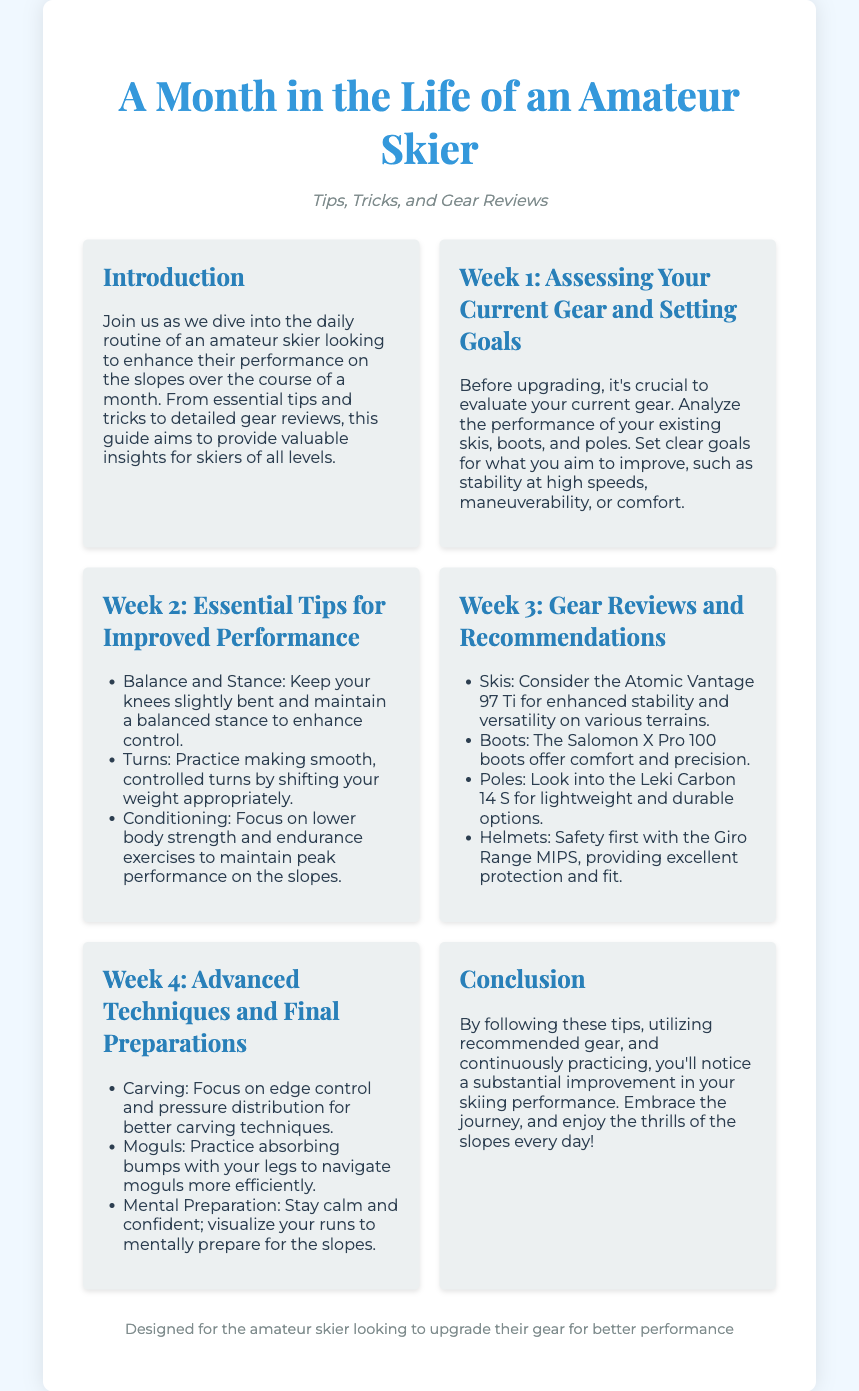What is the title of the document? The title is clearly stated at the top of the Playbill as the main heading.
Answer: A Month in the Life of an Amateur Skier What is the subtitle? The subtitle follows the title and indicates the focus of the content.
Answer: Tips, Tricks, and Gear Reviews What gear is recommended for improved stability? The document includes specific recommendations for gear in Week 3 under gear reviews.
Answer: Atomic Vantage 97 Ti What is one essential tip for improved performance? Essential tips for performance are listed in Week 2 of the document.
Answer: Balance and Stance Which week focuses on advanced techniques? Each week is dedicated to specific themes, and this week is explicitly mentioned.
Answer: Week 4 What is the main focus in Week 1? Week 1's focus is about evaluating existing equipment and setting goals.
Answer: Assessing Your Current Gear and Setting Goals What is the recommended boot for comfort? The gear review section includes specific recommendations for comfort.
Answer: Salomon X Pro 100 Which technique should be practiced for moguls? Advanced techniques outlined in Week 4 provide specific techniques to practice.
Answer: Absorbing bumps with your legs Who is the intended audience of the document? The conclusion and footer specify the target audience.
Answer: Amateur skier 